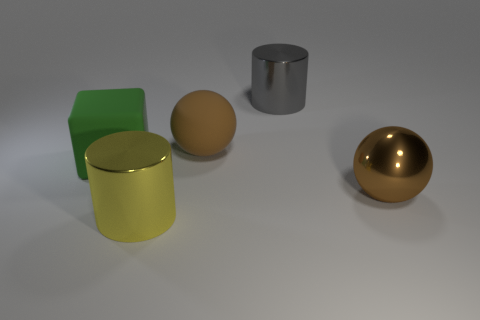Does the large yellow object have the same material as the large gray cylinder?
Provide a succinct answer. Yes. What number of things are either green blocks or large yellow spheres?
Your answer should be compact. 1. Are there fewer big gray metallic cylinders than objects?
Give a very brief answer. Yes. What number of other balls are the same color as the big rubber ball?
Ensure brevity in your answer.  1. Do the large thing that is on the right side of the big gray metallic thing and the matte sphere have the same color?
Your answer should be compact. Yes. There is a big metal thing that is behind the brown matte sphere; what shape is it?
Keep it short and to the point. Cylinder. There is a cylinder on the right side of the big yellow cylinder; is there a thing left of it?
Provide a short and direct response. Yes. How many other large blocks have the same material as the big green cube?
Offer a terse response. 0. How big is the object that is to the left of the cylinder in front of the brown ball that is to the right of the gray metallic cylinder?
Offer a terse response. Large. What number of balls are on the right side of the large gray cylinder?
Offer a terse response. 1. 